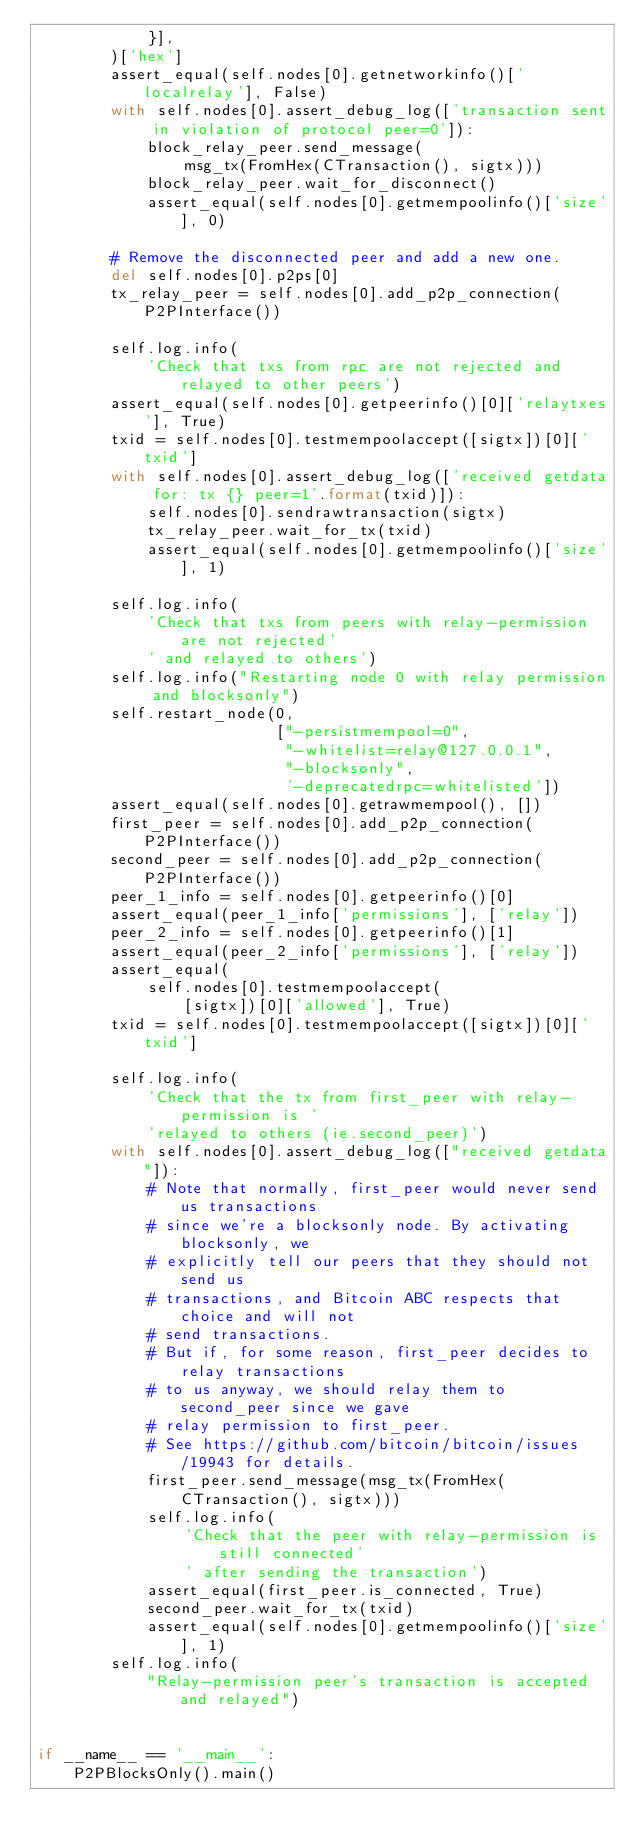<code> <loc_0><loc_0><loc_500><loc_500><_Python_>            }],
        )['hex']
        assert_equal(self.nodes[0].getnetworkinfo()['localrelay'], False)
        with self.nodes[0].assert_debug_log(['transaction sent in violation of protocol peer=0']):
            block_relay_peer.send_message(
                msg_tx(FromHex(CTransaction(), sigtx)))
            block_relay_peer.wait_for_disconnect()
            assert_equal(self.nodes[0].getmempoolinfo()['size'], 0)

        # Remove the disconnected peer and add a new one.
        del self.nodes[0].p2ps[0]
        tx_relay_peer = self.nodes[0].add_p2p_connection(P2PInterface())

        self.log.info(
            'Check that txs from rpc are not rejected and relayed to other peers')
        assert_equal(self.nodes[0].getpeerinfo()[0]['relaytxes'], True)
        txid = self.nodes[0].testmempoolaccept([sigtx])[0]['txid']
        with self.nodes[0].assert_debug_log(['received getdata for: tx {} peer=1'.format(txid)]):
            self.nodes[0].sendrawtransaction(sigtx)
            tx_relay_peer.wait_for_tx(txid)
            assert_equal(self.nodes[0].getmempoolinfo()['size'], 1)

        self.log.info(
            'Check that txs from peers with relay-permission are not rejected'
            ' and relayed to others')
        self.log.info("Restarting node 0 with relay permission and blocksonly")
        self.restart_node(0,
                          ["-persistmempool=0",
                           "-whitelist=relay@127.0.0.1",
                           "-blocksonly",
                           '-deprecatedrpc=whitelisted'])
        assert_equal(self.nodes[0].getrawmempool(), [])
        first_peer = self.nodes[0].add_p2p_connection(P2PInterface())
        second_peer = self.nodes[0].add_p2p_connection(P2PInterface())
        peer_1_info = self.nodes[0].getpeerinfo()[0]
        assert_equal(peer_1_info['permissions'], ['relay'])
        peer_2_info = self.nodes[0].getpeerinfo()[1]
        assert_equal(peer_2_info['permissions'], ['relay'])
        assert_equal(
            self.nodes[0].testmempoolaccept(
                [sigtx])[0]['allowed'], True)
        txid = self.nodes[0].testmempoolaccept([sigtx])[0]['txid']

        self.log.info(
            'Check that the tx from first_peer with relay-permission is '
            'relayed to others (ie.second_peer)')
        with self.nodes[0].assert_debug_log(["received getdata"]):
            # Note that normally, first_peer would never send us transactions
            # since we're a blocksonly node. By activating blocksonly, we
            # explicitly tell our peers that they should not send us
            # transactions, and Bitcoin ABC respects that choice and will not
            # send transactions.
            # But if, for some reason, first_peer decides to relay transactions
            # to us anyway, we should relay them to second_peer since we gave
            # relay permission to first_peer.
            # See https://github.com/bitcoin/bitcoin/issues/19943 for details.
            first_peer.send_message(msg_tx(FromHex(CTransaction(), sigtx)))
            self.log.info(
                'Check that the peer with relay-permission is still connected'
                ' after sending the transaction')
            assert_equal(first_peer.is_connected, True)
            second_peer.wait_for_tx(txid)
            assert_equal(self.nodes[0].getmempoolinfo()['size'], 1)
        self.log.info(
            "Relay-permission peer's transaction is accepted and relayed")


if __name__ == '__main__':
    P2PBlocksOnly().main()
</code> 